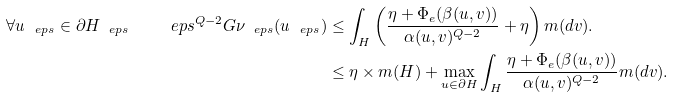<formula> <loc_0><loc_0><loc_500><loc_500>\forall u _ { \ e p s } \in \partial H _ { \ e p s } \quad \ e p s ^ { Q - 2 } G \nu _ { \ e p s } ( u _ { \ e p s } ) & \leq \int _ { H } \left ( \frac { \eta + \Phi _ { e } ( \beta ( u , v ) ) } { \alpha ( u , v ) ^ { Q - 2 } } + \eta \right ) m ( d v ) . \\ & \leq \eta \times m ( H ) + \max _ { u \in \partial H } \int _ { H } \frac { \eta + \Phi _ { e } ( \beta ( u , v ) ) } { \alpha ( u , v ) ^ { Q - 2 } } m ( d v ) .</formula> 